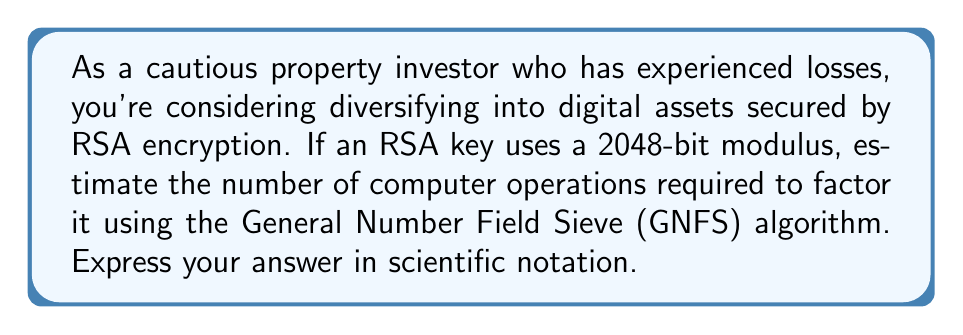What is the answer to this math problem? To estimate the computational resources required for factoring a 2048-bit RSA modulus using the General Number Field Sieve (GNFS) algorithm, we'll follow these steps:

1. The complexity of GNFS for factoring an integer $n$ is approximately:

   $$O(\exp((c + o(1))(\ln n)^{1/3}(\ln \ln n)^{2/3}))$$

   where $c \approx 1.923$.

2. For a 2048-bit modulus, $n \approx 2^{2048}$.

3. Substituting this into the complexity formula:

   $$\exp((1.923 + o(1))(\ln 2^{2048})^{1/3}(\ln \ln 2^{2048})^{2/3})$$

4. Simplify:
   $$\ln 2^{2048} = 2048 \ln 2$$
   $$\ln \ln 2^{2048} = \ln(2048 \ln 2)$$

5. Calculate:
   $$(\ln 2^{2048})^{1/3} \approx 9.63$$
   $$(\ln \ln 2^{2048})^{2/3} \approx 3.03$$

6. Multiply:
   $$1.923 \cdot 9.63 \cdot 3.03 \approx 55.98$$

7. The final estimation:
   $$\exp(55.98) \approx 2.19 \times 10^{24}$$

This represents the approximate number of computer operations required to factor a 2048-bit RSA modulus using the GNFS algorithm.
Answer: $2.19 \times 10^{24}$ operations 